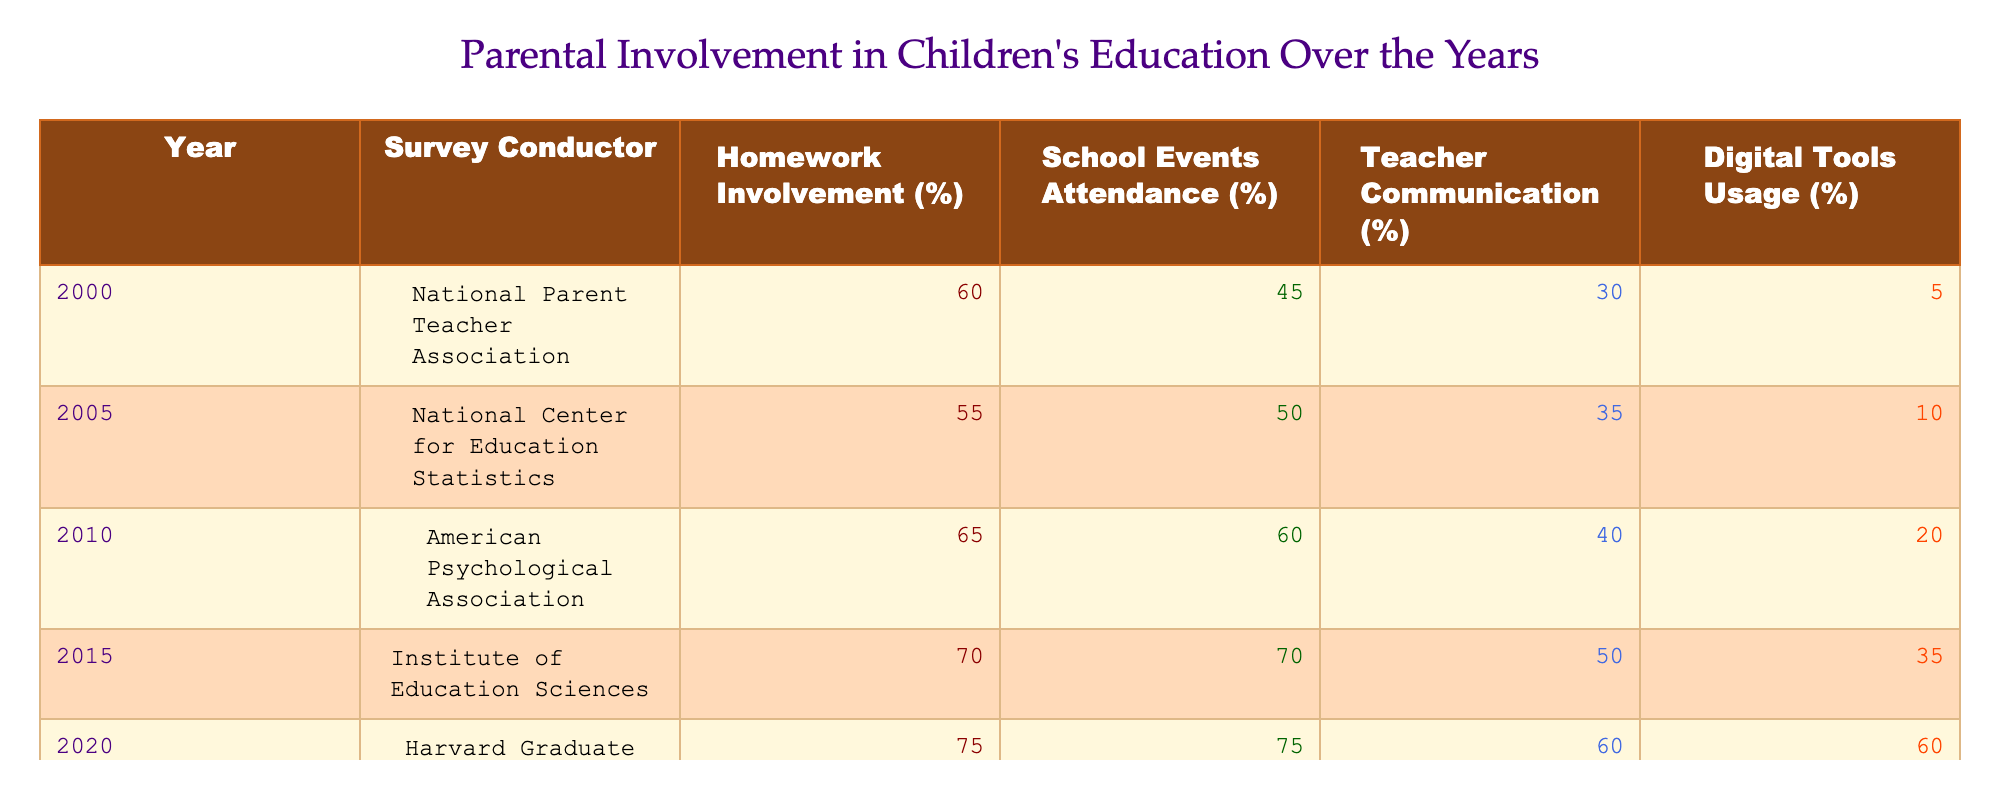What was the percentage of parents involved in homework in 2010? According to the table, the percentage of parents involved in homework in 2010 is listed as 65%.
Answer: 65% What survey conducted in 2023 reported the highest percentage of parents attending school events? The table shows that in 2023, the National Education Association reported the highest percentage of parents attending school events, which is 80%.
Answer: 80% How much did the percentage of parents communicating with teachers increase from 2000 to 2023? In 2000, the percentage was 30% and in 2023 it was 70%. To find the increase, subtract: 70% - 30% = 40%.
Answer: 40% True or False: The percentage of parents using digital tools for education in 2015 was higher than in 2000. In 2015, the percentage was 35%, whereas in 2000 it was only 5%. Hence, 35% is indeed greater than 5%.
Answer: True What is the average percentage of parents attending school events across all surveyed years? To find the average, sum the percentages from the table: 45 + 50 + 60 + 70 + 75 + 80 = 410. There are 6 years, so divide: 410 / 6 = 68.33.
Answer: 68.33 What percentage of parents involved in homework in 2020 was higher than that of the percentage in 2010? In the table, homework involvement was 75% in 2020 and 65% in 2010. Therefore, yes, 75% is higher than 65%.
Answer: Yes What was the percentage increase in parents using digital tools for education from 2010 to 2023? In 2010, the percentage of parents using digital tools was 20%, and in 2023 it was 75%. The increase is calculated as: 75% - 20% = 55%.
Answer: 55% In which year did the highest percentage of parents attend school events, and what was that percentage? The table shows that the highest percentage of parents attending school events was in 2023 at 80%.
Answer: 80% in 2023 Which survey conducted reported the lowest percentage of parents using digital tools for education? The table indicates that the survey conducted in 2000 reported the lowest percentage of parents using digital tools for education at 5%.
Answer: 5% in 2000 